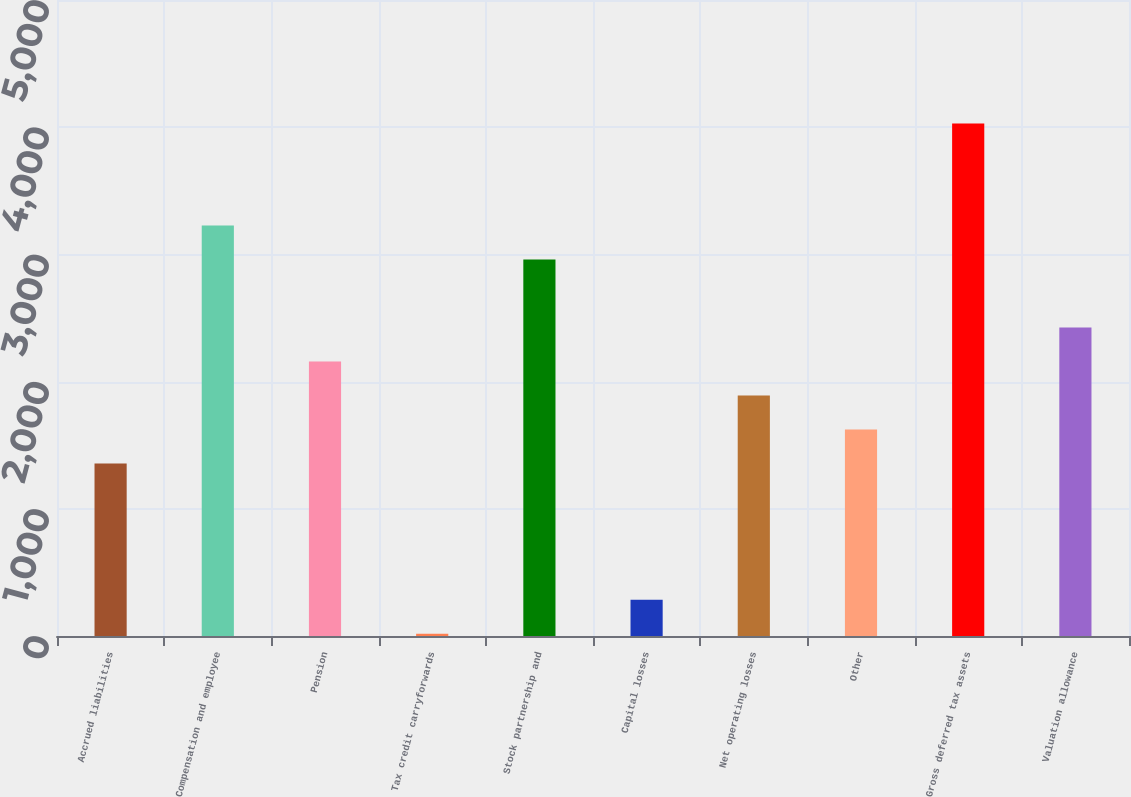<chart> <loc_0><loc_0><loc_500><loc_500><bar_chart><fcel>Accrued liabilities<fcel>Compensation and employee<fcel>Pension<fcel>Tax credit carryforwards<fcel>Stock partnership and<fcel>Capital losses<fcel>Net operating losses<fcel>Other<fcel>Gross deferred tax assets<fcel>Valuation allowance<nl><fcel>1355.6<fcel>3227.68<fcel>2157.92<fcel>18.4<fcel>2960.24<fcel>285.84<fcel>1890.48<fcel>1623.04<fcel>4030<fcel>2425.36<nl></chart> 